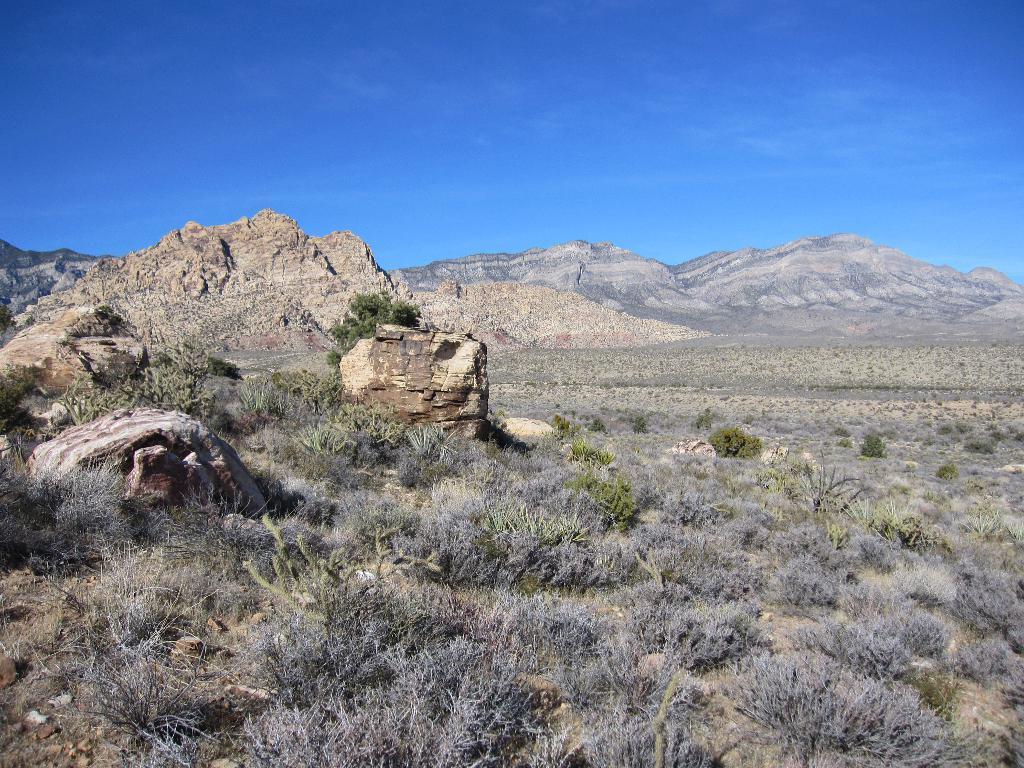In one or two sentences, can you explain what this image depicts? In the image we can see, mountain, grass and a blue sky. 